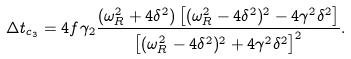<formula> <loc_0><loc_0><loc_500><loc_500>\Delta t _ { c _ { 3 } } = 4 f \gamma _ { 2 } \frac { ( \omega _ { R } ^ { 2 } + 4 \delta ^ { 2 } ) \left [ ( \omega _ { R } ^ { 2 } - 4 \delta ^ { 2 } ) ^ { 2 } - 4 \gamma ^ { 2 } \delta ^ { 2 } \right ] } { \left [ ( \omega _ { R } ^ { 2 } - 4 \delta ^ { 2 } ) ^ { 2 } + 4 \gamma ^ { 2 } \delta ^ { 2 } \right ] ^ { 2 } } .</formula> 